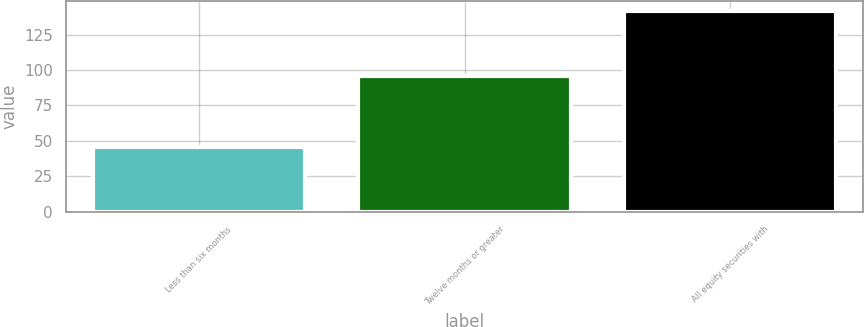Convert chart to OTSL. <chart><loc_0><loc_0><loc_500><loc_500><bar_chart><fcel>Less than six months<fcel>Twelve months or greater<fcel>All equity securities with<nl><fcel>46<fcel>96<fcel>142<nl></chart> 